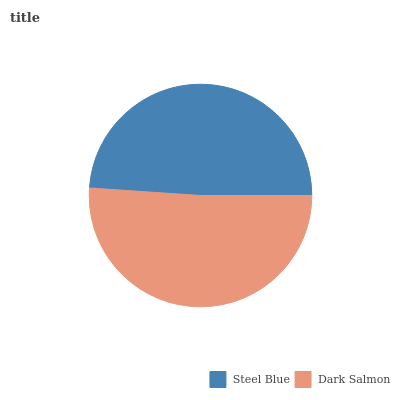Is Steel Blue the minimum?
Answer yes or no. Yes. Is Dark Salmon the maximum?
Answer yes or no. Yes. Is Dark Salmon the minimum?
Answer yes or no. No. Is Dark Salmon greater than Steel Blue?
Answer yes or no. Yes. Is Steel Blue less than Dark Salmon?
Answer yes or no. Yes. Is Steel Blue greater than Dark Salmon?
Answer yes or no. No. Is Dark Salmon less than Steel Blue?
Answer yes or no. No. Is Dark Salmon the high median?
Answer yes or no. Yes. Is Steel Blue the low median?
Answer yes or no. Yes. Is Steel Blue the high median?
Answer yes or no. No. Is Dark Salmon the low median?
Answer yes or no. No. 